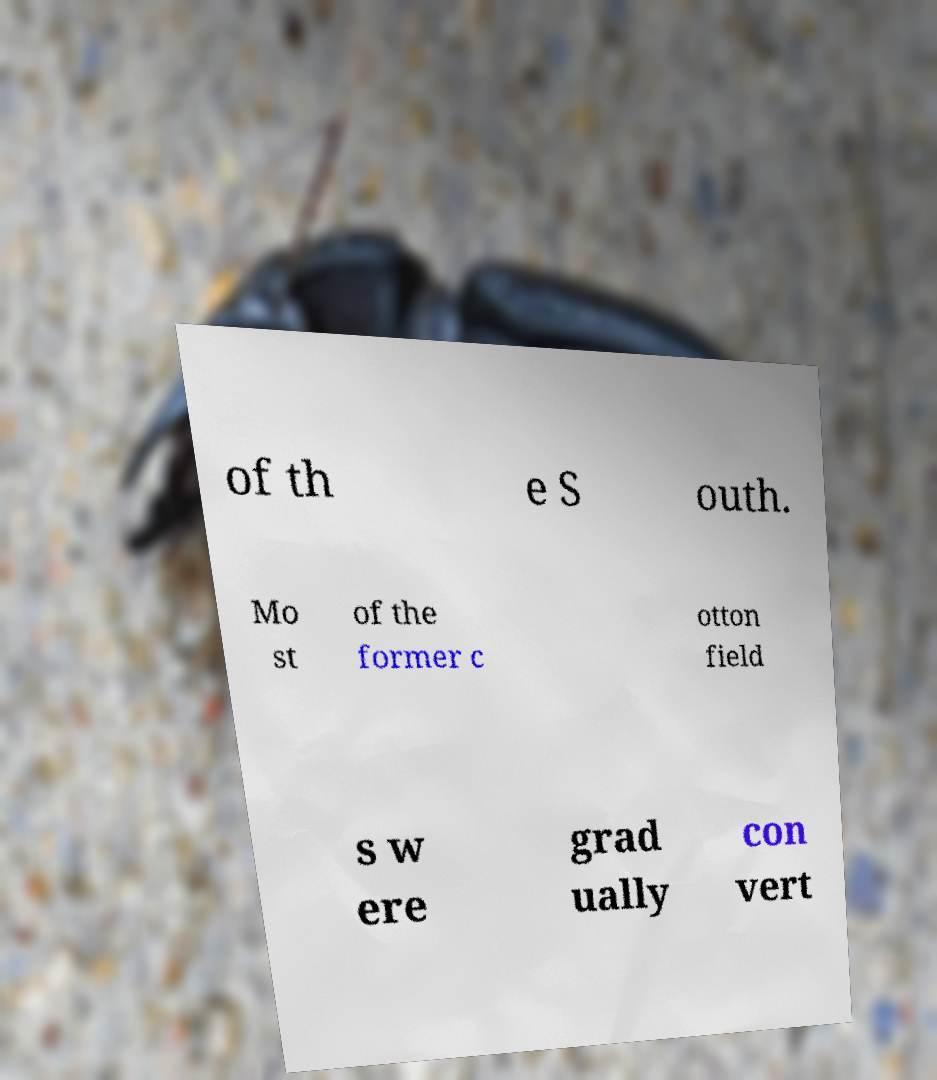Could you extract and type out the text from this image? of th e S outh. Mo st of the former c otton field s w ere grad ually con vert 